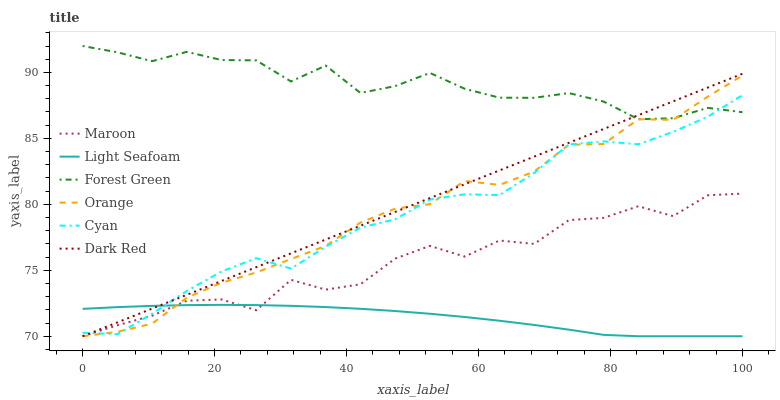Does Light Seafoam have the minimum area under the curve?
Answer yes or no. Yes. Does Forest Green have the maximum area under the curve?
Answer yes or no. Yes. Does Maroon have the minimum area under the curve?
Answer yes or no. No. Does Maroon have the maximum area under the curve?
Answer yes or no. No. Is Dark Red the smoothest?
Answer yes or no. Yes. Is Maroon the roughest?
Answer yes or no. Yes. Is Forest Green the smoothest?
Answer yes or no. No. Is Forest Green the roughest?
Answer yes or no. No. Does Dark Red have the lowest value?
Answer yes or no. Yes. Does Forest Green have the lowest value?
Answer yes or no. No. Does Forest Green have the highest value?
Answer yes or no. Yes. Does Maroon have the highest value?
Answer yes or no. No. Is Maroon less than Forest Green?
Answer yes or no. Yes. Is Forest Green greater than Light Seafoam?
Answer yes or no. Yes. Does Orange intersect Maroon?
Answer yes or no. Yes. Is Orange less than Maroon?
Answer yes or no. No. Is Orange greater than Maroon?
Answer yes or no. No. Does Maroon intersect Forest Green?
Answer yes or no. No. 